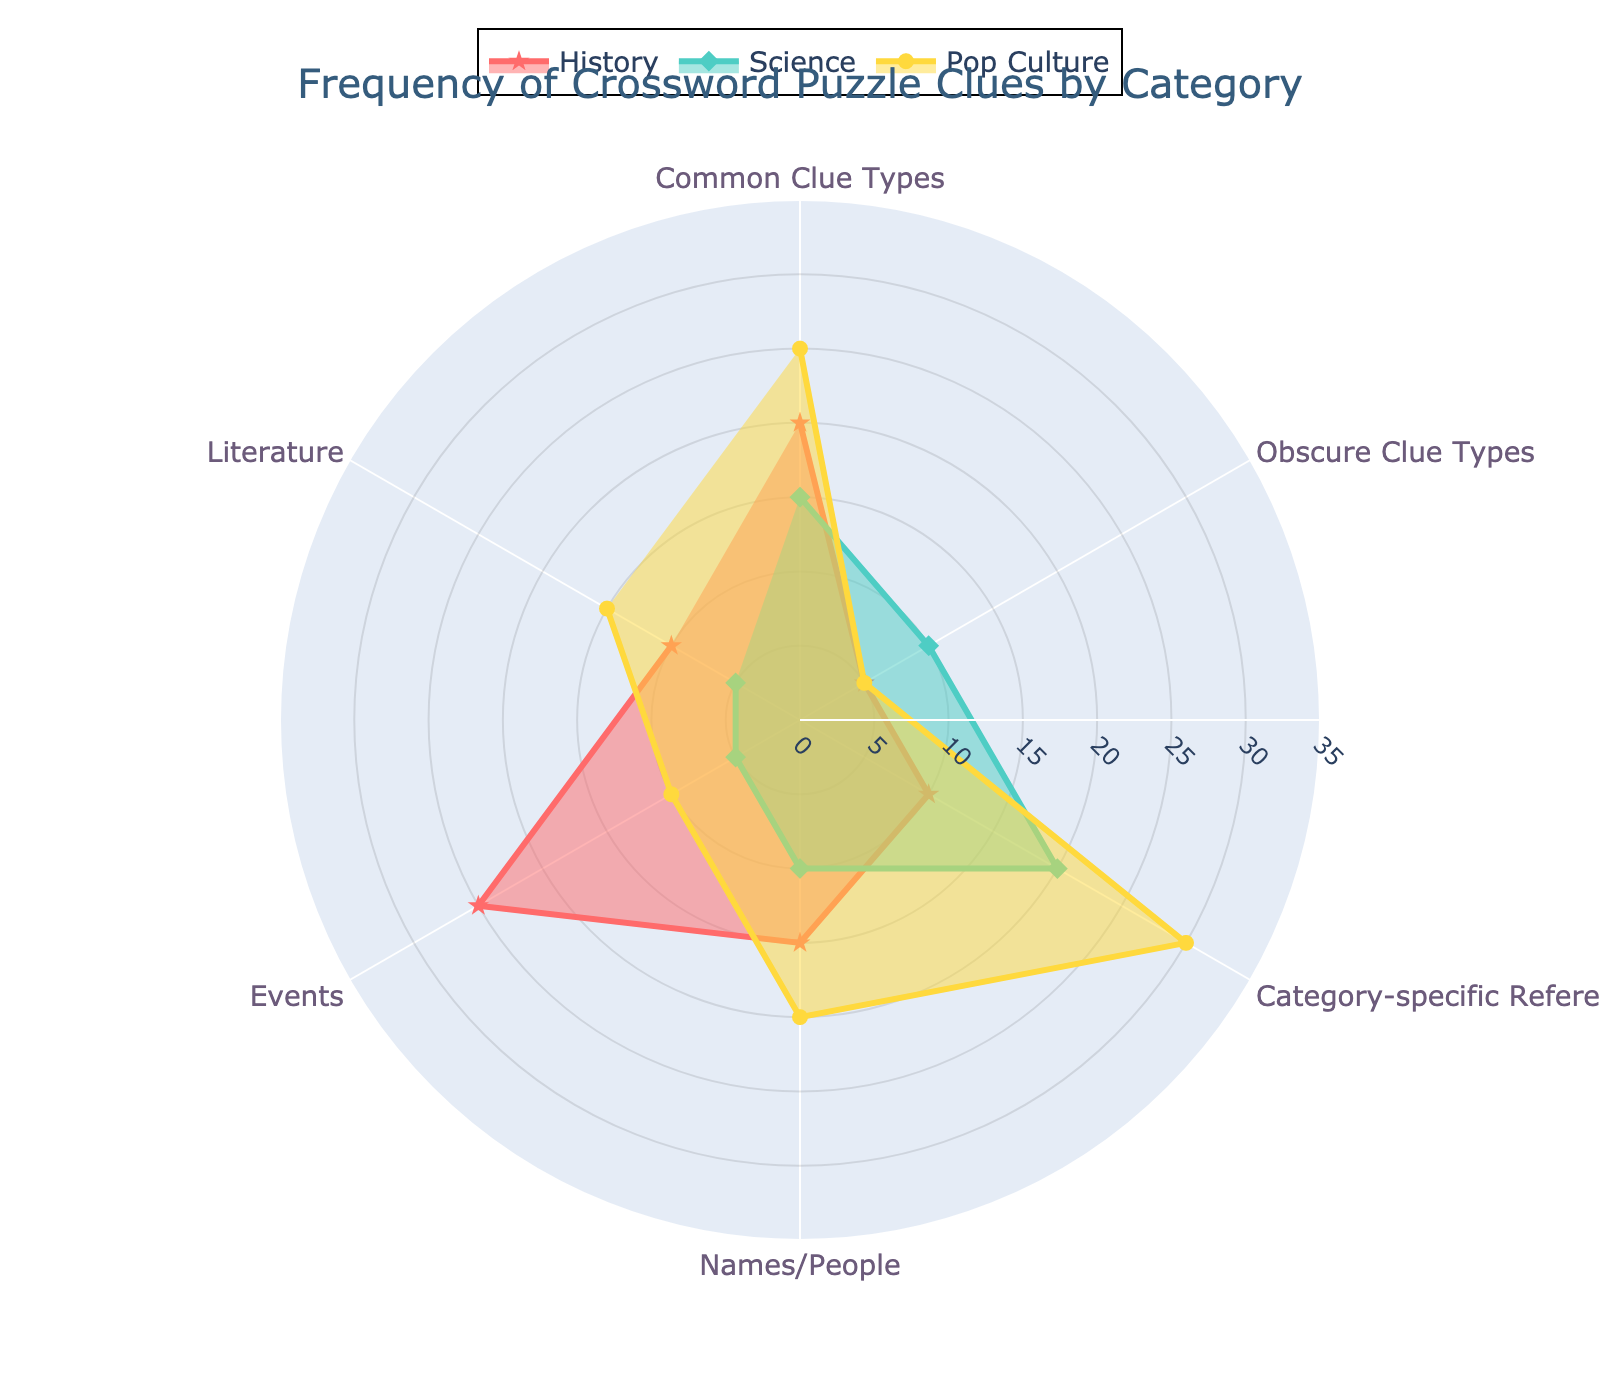What's the title of the plot? The title of the plot is usually positioned at the top of the figure. Reading the title, we see it mentions the frequency of crossword puzzle clues categorized by various domains.
Answer: Frequency of Crossword Puzzle Clues by Category Which category has the highest value in "History"? To determine this, check the "History" line across all sections. The highest value lies in the "Events" category.
Answer: Events How many categories are assessed in the plot? The categories are listed along the axes of the radar chart. Counting them, we see six categories total.
Answer: Six For the "Pop Culture" category, which section has the lowest value? By following the "Pop Culture" line to its lowest point, we see "Events" has the lowest value.
Answer: Events What's the difference between "Common Clue Types" for "History" and "Science"? Look at the values for "Common Clue Types" under both "History" (20) and "Science" (15). The difference is calculated as 20 - 15.
Answer: 5 Which category has the most balanced (closest) values between "History" and "Science"? Examine each category's values for "History" and "Science" to find the smallest difference. "Literature" has History at 10 and Science at 5, resulting in a difference of 5.
Answer: Literature Which section for "Science" has the highest value? Trace the "Science" line and identify the highest point. "Category-specific References" has the highest value.
Answer: Category-specific References What is the combined value of "Names/People" across all categories? Sum the "Names/People" values for History (15), Science (10), and Pop Culture (20), i.e., 15 + 10 + 20.
Answer: 45 Is the value for "Category-specific References" in "Pop Culture" greater than twice that in "History"? "Pop Culture" has 30, "History" has 10. Twice the value in "History" is 10 * 2 = 20. Since 30 is greater than 20, the condition is true.
Answer: Yes 